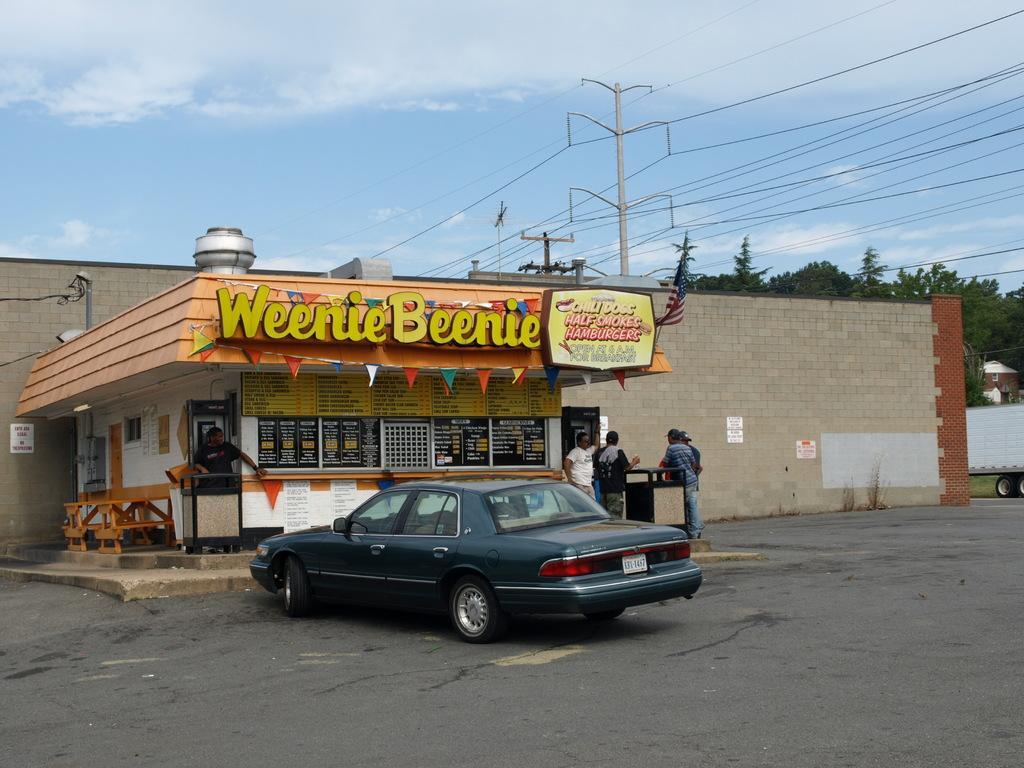How would you summarize this image in a sentence or two? In this picture there is a car in the center of the image and there is a stall in the center of the image, there are people those who are standing in the center of the image. 